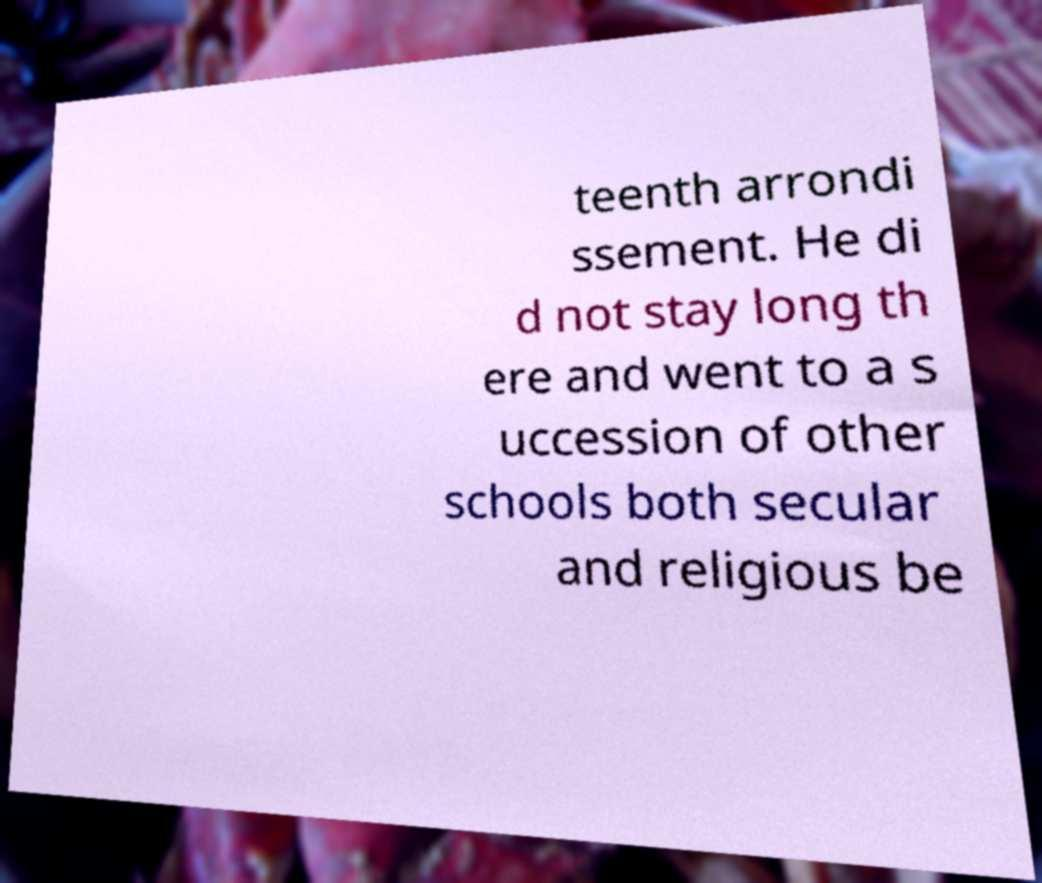Please read and relay the text visible in this image. What does it say? teenth arrondi ssement. He di d not stay long th ere and went to a s uccession of other schools both secular and religious be 